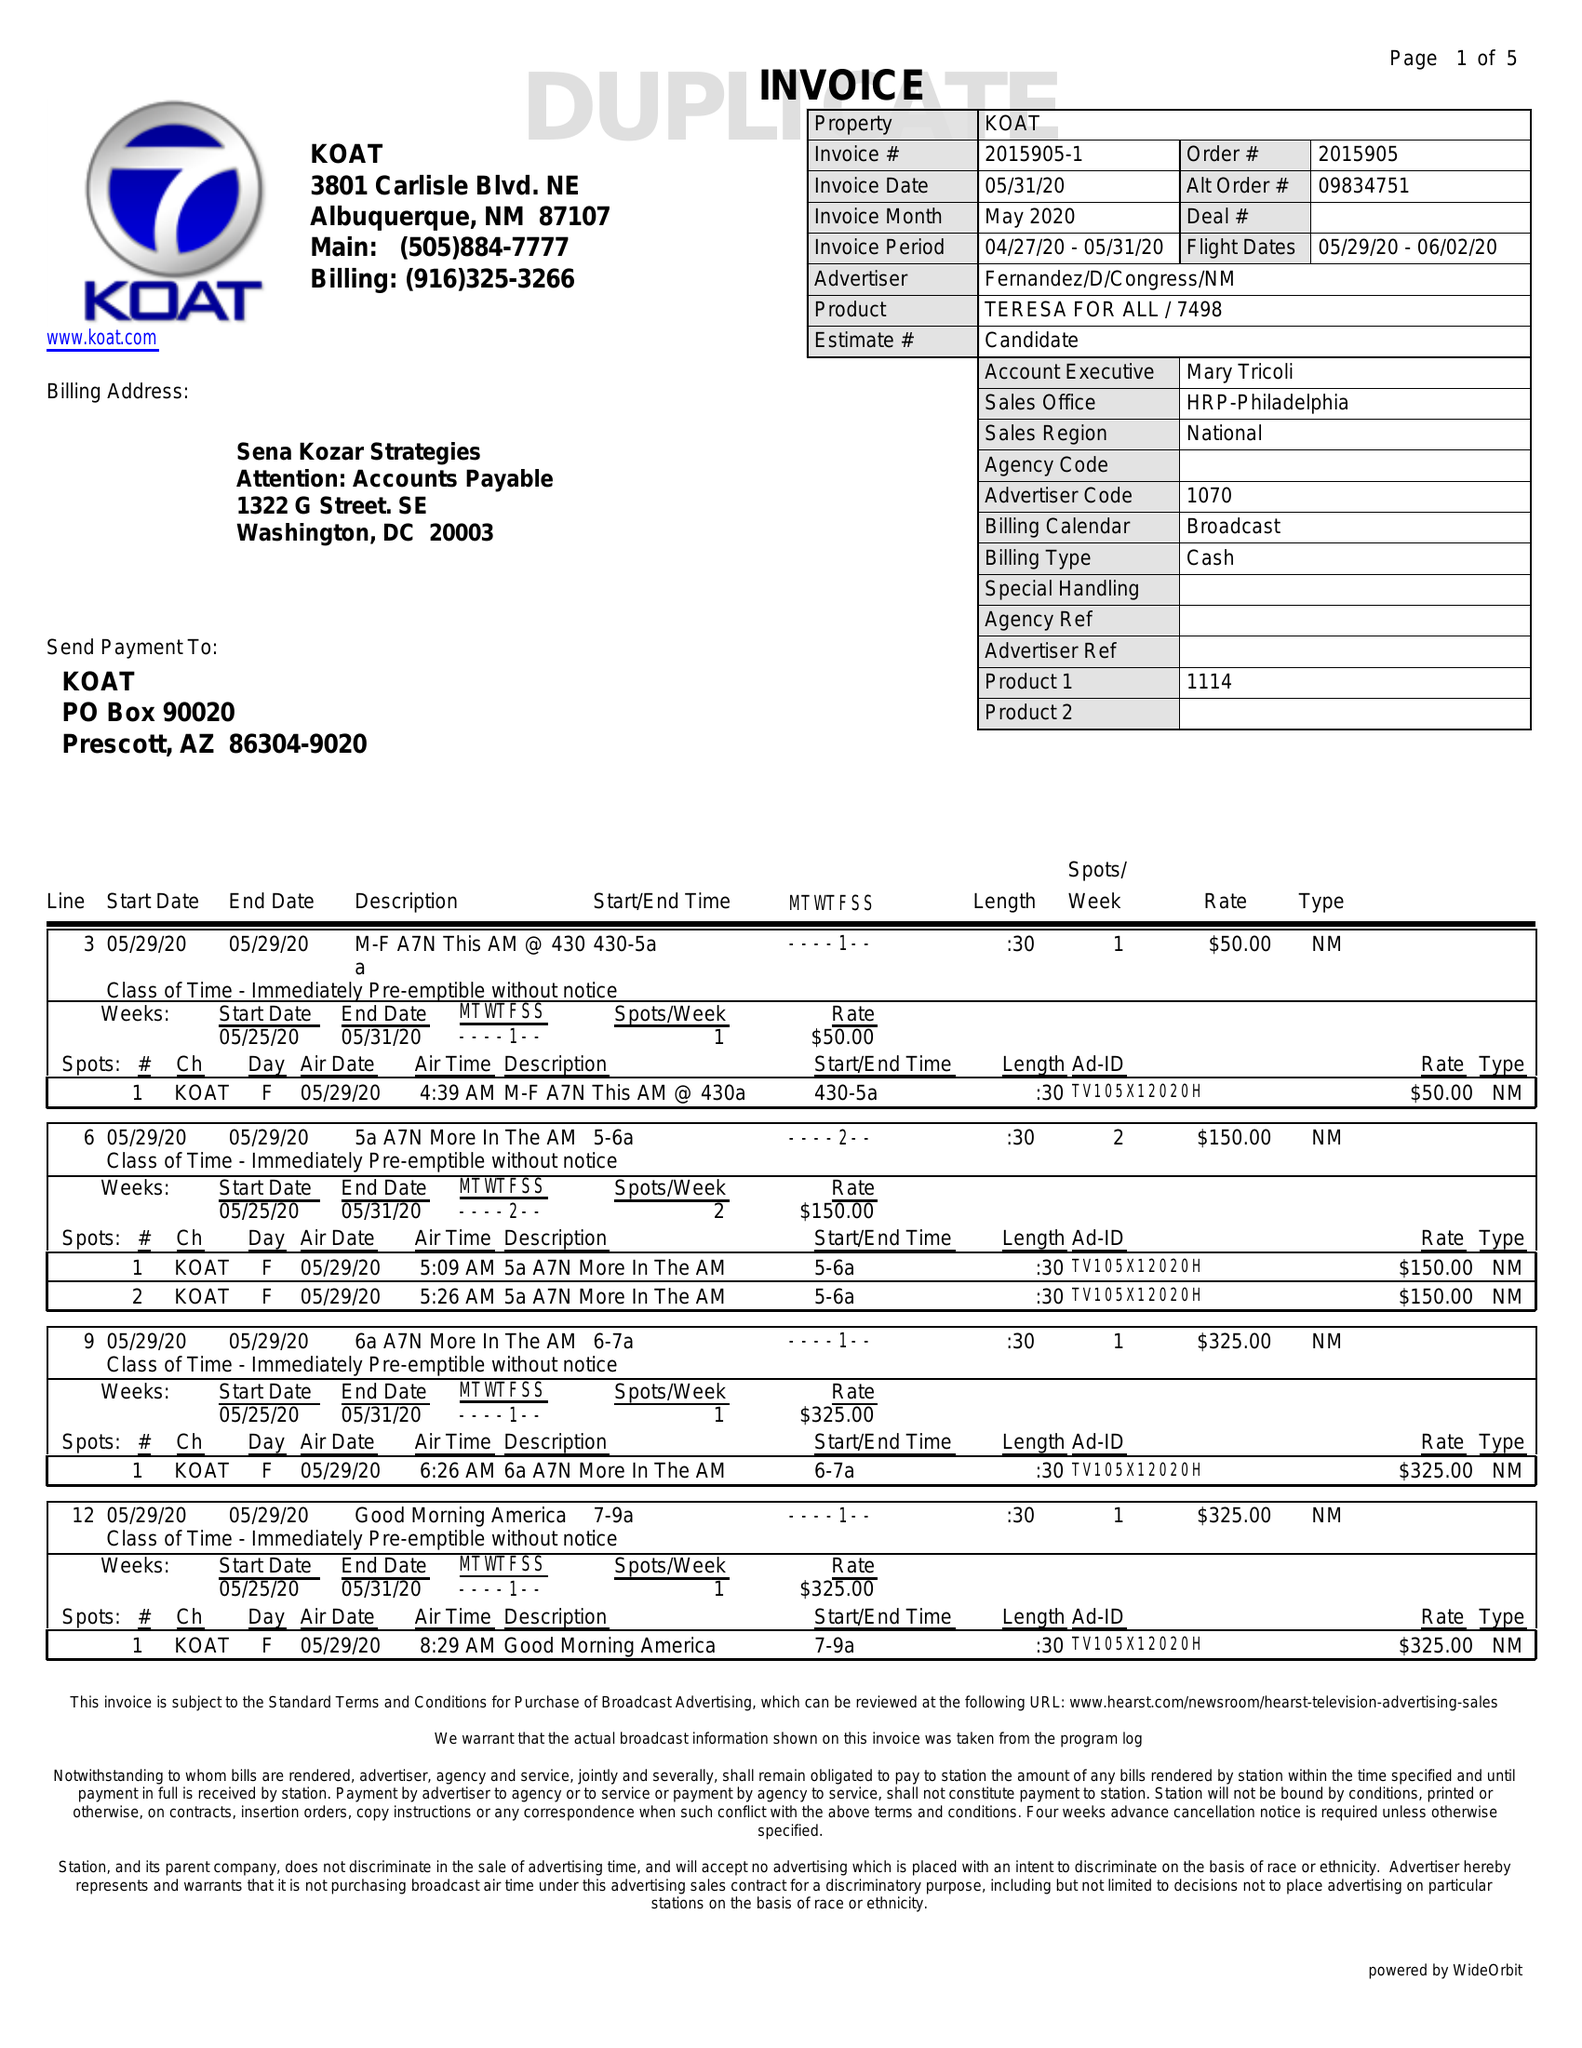What is the value for the gross_amount?
Answer the question using a single word or phrase. 5925.00 